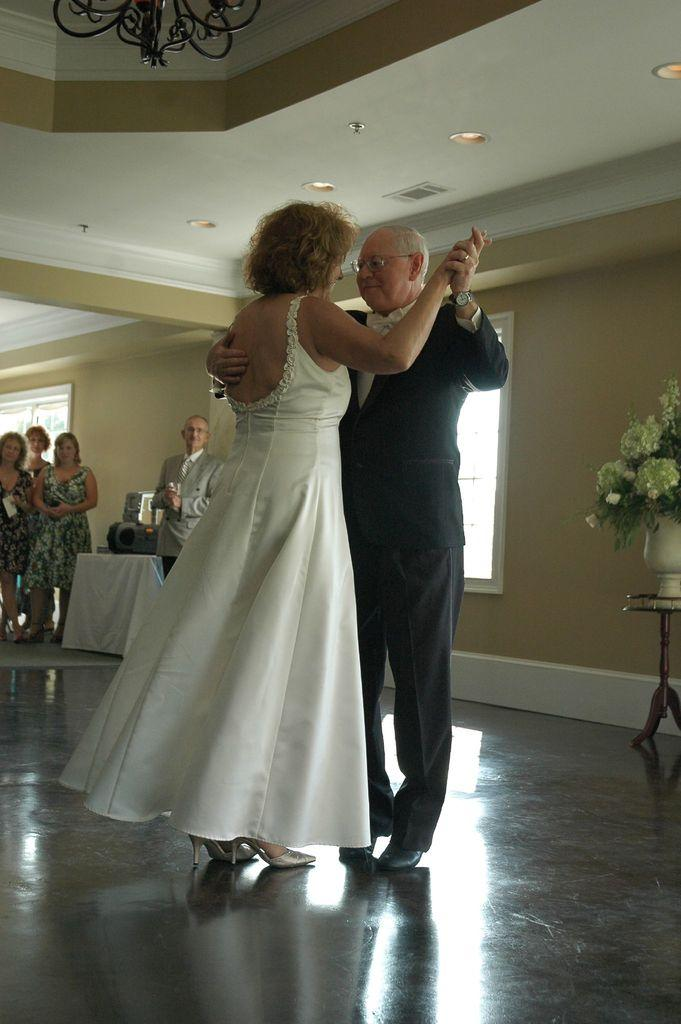What are the people in the center of the image doing? The people in the center of the image are dancing. What can be seen in the background of the image? There is a wall and people in the background of the image. Is there any architectural feature visible in the background? Yes, there is a window in the background of the image. What type of knife is being used by the dancers in the image? There is no knife present in the image; the people are dancing. What caption is written on the wall in the background of the image? There is no caption visible on the wall in the image. 